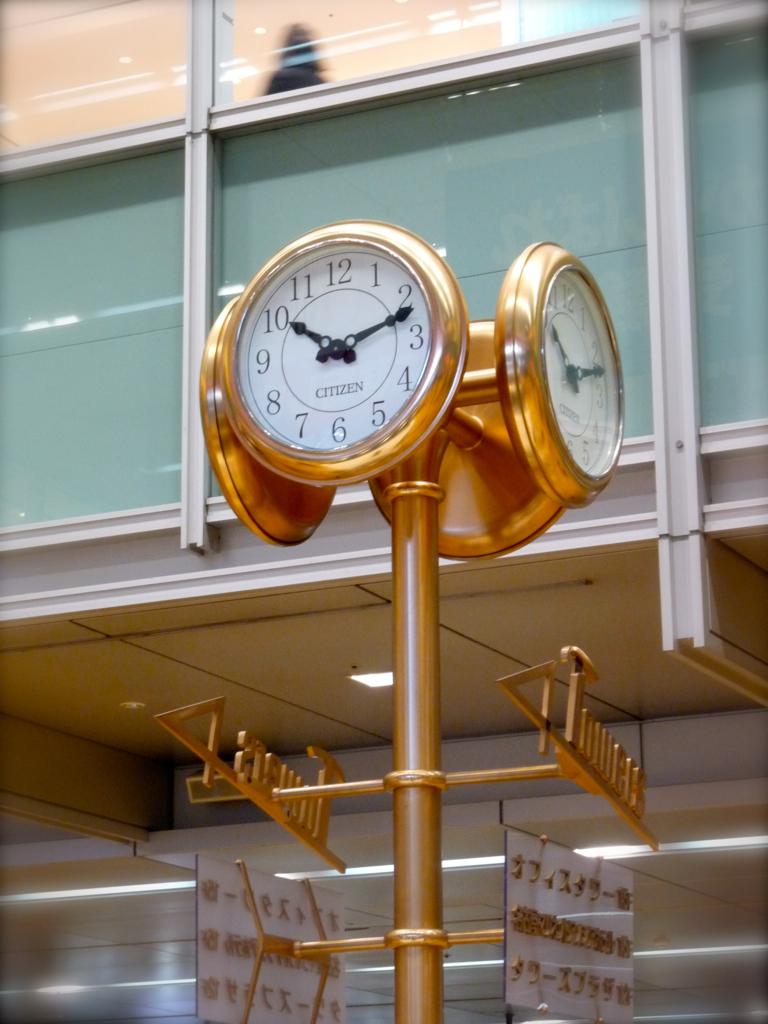What time is it?
Your answer should be compact. 10:12. What is written on the signs under the clock face?
Make the answer very short. Towers. 